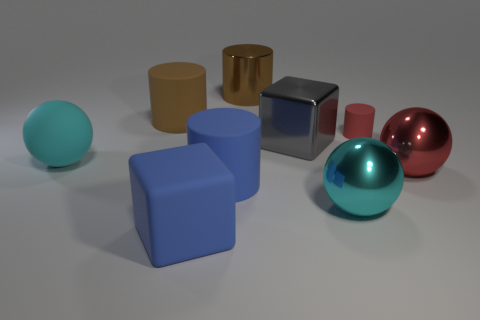Is there anything else that is made of the same material as the tiny cylinder?
Offer a very short reply. Yes. How many small objects are either cyan metallic things or blue rubber blocks?
Ensure brevity in your answer.  0. What number of objects are either big metallic spheres that are behind the large cyan metal thing or cyan balls?
Give a very brief answer. 3. Is the color of the large rubber sphere the same as the tiny rubber thing?
Give a very brief answer. No. What number of other objects are the same shape as the gray thing?
Your answer should be compact. 1. What number of gray things are large cylinders or metallic things?
Your answer should be compact. 1. There is a cube that is made of the same material as the red cylinder; what is its color?
Make the answer very short. Blue. Is the material of the brown object to the left of the big brown metal cylinder the same as the cyan object right of the big cyan matte sphere?
Offer a very short reply. No. There is a rubber cylinder that is the same color as the metal cylinder; what size is it?
Your answer should be very brief. Large. There is a large sphere left of the blue block; what is its material?
Offer a very short reply. Rubber. 